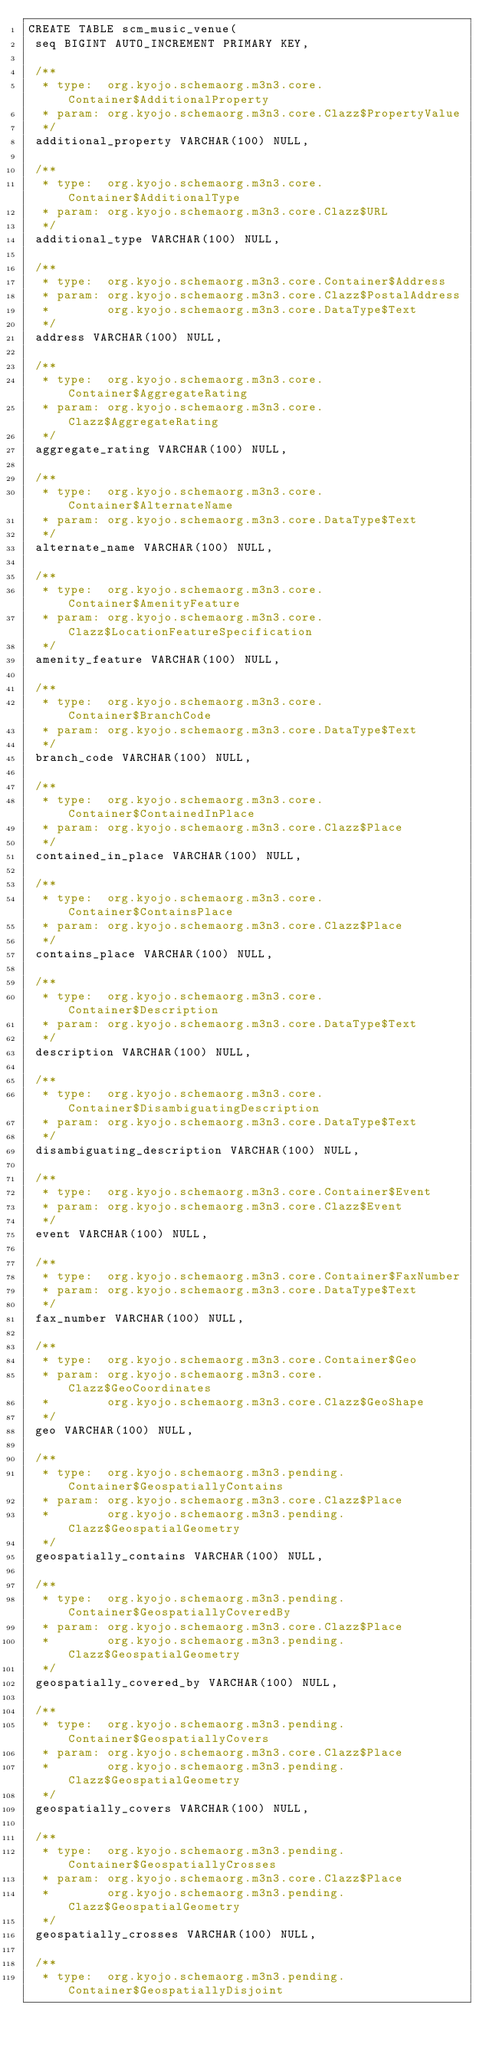Convert code to text. <code><loc_0><loc_0><loc_500><loc_500><_SQL_>CREATE TABLE scm_music_venue(
 seq BIGINT AUTO_INCREMENT PRIMARY KEY,

 /**
  * type:  org.kyojo.schemaorg.m3n3.core.Container$AdditionalProperty
  * param: org.kyojo.schemaorg.m3n3.core.Clazz$PropertyValue
  */
 additional_property VARCHAR(100) NULL,

 /**
  * type:  org.kyojo.schemaorg.m3n3.core.Container$AdditionalType
  * param: org.kyojo.schemaorg.m3n3.core.Clazz$URL
  */
 additional_type VARCHAR(100) NULL,

 /**
  * type:  org.kyojo.schemaorg.m3n3.core.Container$Address
  * param: org.kyojo.schemaorg.m3n3.core.Clazz$PostalAddress
  *        org.kyojo.schemaorg.m3n3.core.DataType$Text
  */
 address VARCHAR(100) NULL,

 /**
  * type:  org.kyojo.schemaorg.m3n3.core.Container$AggregateRating
  * param: org.kyojo.schemaorg.m3n3.core.Clazz$AggregateRating
  */
 aggregate_rating VARCHAR(100) NULL,

 /**
  * type:  org.kyojo.schemaorg.m3n3.core.Container$AlternateName
  * param: org.kyojo.schemaorg.m3n3.core.DataType$Text
  */
 alternate_name VARCHAR(100) NULL,

 /**
  * type:  org.kyojo.schemaorg.m3n3.core.Container$AmenityFeature
  * param: org.kyojo.schemaorg.m3n3.core.Clazz$LocationFeatureSpecification
  */
 amenity_feature VARCHAR(100) NULL,

 /**
  * type:  org.kyojo.schemaorg.m3n3.core.Container$BranchCode
  * param: org.kyojo.schemaorg.m3n3.core.DataType$Text
  */
 branch_code VARCHAR(100) NULL,

 /**
  * type:  org.kyojo.schemaorg.m3n3.core.Container$ContainedInPlace
  * param: org.kyojo.schemaorg.m3n3.core.Clazz$Place
  */
 contained_in_place VARCHAR(100) NULL,

 /**
  * type:  org.kyojo.schemaorg.m3n3.core.Container$ContainsPlace
  * param: org.kyojo.schemaorg.m3n3.core.Clazz$Place
  */
 contains_place VARCHAR(100) NULL,

 /**
  * type:  org.kyojo.schemaorg.m3n3.core.Container$Description
  * param: org.kyojo.schemaorg.m3n3.core.DataType$Text
  */
 description VARCHAR(100) NULL,

 /**
  * type:  org.kyojo.schemaorg.m3n3.core.Container$DisambiguatingDescription
  * param: org.kyojo.schemaorg.m3n3.core.DataType$Text
  */
 disambiguating_description VARCHAR(100) NULL,

 /**
  * type:  org.kyojo.schemaorg.m3n3.core.Container$Event
  * param: org.kyojo.schemaorg.m3n3.core.Clazz$Event
  */
 event VARCHAR(100) NULL,

 /**
  * type:  org.kyojo.schemaorg.m3n3.core.Container$FaxNumber
  * param: org.kyojo.schemaorg.m3n3.core.DataType$Text
  */
 fax_number VARCHAR(100) NULL,

 /**
  * type:  org.kyojo.schemaorg.m3n3.core.Container$Geo
  * param: org.kyojo.schemaorg.m3n3.core.Clazz$GeoCoordinates
  *        org.kyojo.schemaorg.m3n3.core.Clazz$GeoShape
  */
 geo VARCHAR(100) NULL,

 /**
  * type:  org.kyojo.schemaorg.m3n3.pending.Container$GeospatiallyContains
  * param: org.kyojo.schemaorg.m3n3.core.Clazz$Place
  *        org.kyojo.schemaorg.m3n3.pending.Clazz$GeospatialGeometry
  */
 geospatially_contains VARCHAR(100) NULL,

 /**
  * type:  org.kyojo.schemaorg.m3n3.pending.Container$GeospatiallyCoveredBy
  * param: org.kyojo.schemaorg.m3n3.core.Clazz$Place
  *        org.kyojo.schemaorg.m3n3.pending.Clazz$GeospatialGeometry
  */
 geospatially_covered_by VARCHAR(100) NULL,

 /**
  * type:  org.kyojo.schemaorg.m3n3.pending.Container$GeospatiallyCovers
  * param: org.kyojo.schemaorg.m3n3.core.Clazz$Place
  *        org.kyojo.schemaorg.m3n3.pending.Clazz$GeospatialGeometry
  */
 geospatially_covers VARCHAR(100) NULL,

 /**
  * type:  org.kyojo.schemaorg.m3n3.pending.Container$GeospatiallyCrosses
  * param: org.kyojo.schemaorg.m3n3.core.Clazz$Place
  *        org.kyojo.schemaorg.m3n3.pending.Clazz$GeospatialGeometry
  */
 geospatially_crosses VARCHAR(100) NULL,

 /**
  * type:  org.kyojo.schemaorg.m3n3.pending.Container$GeospatiallyDisjoint</code> 